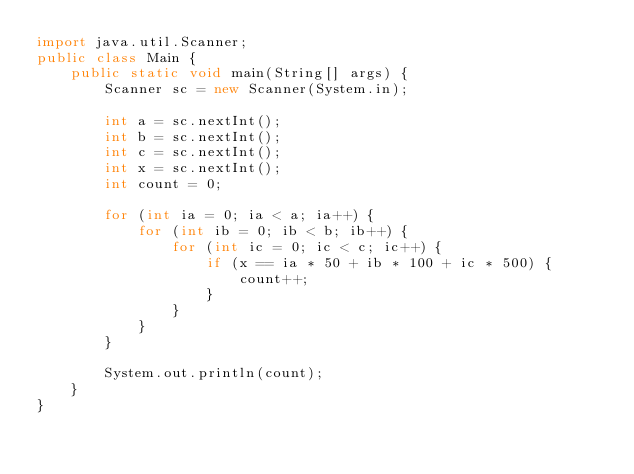Convert code to text. <code><loc_0><loc_0><loc_500><loc_500><_Java_>import java.util.Scanner;
public class Main {
	public static void main(String[] args) {
		Scanner sc = new Scanner(System.in);

		int a = sc.nextInt();
		int b = sc.nextInt();
		int c = sc.nextInt();
		int x = sc.nextInt();
		int count = 0;

		for (int ia = 0; ia < a; ia++) {
			for (int ib = 0; ib < b; ib++) {
				for (int ic = 0; ic < c; ic++) {
					if (x == ia * 50 + ib * 100 + ic * 500) {
						count++;
					}
				}
			}
		}

		System.out.println(count);
	}
}</code> 